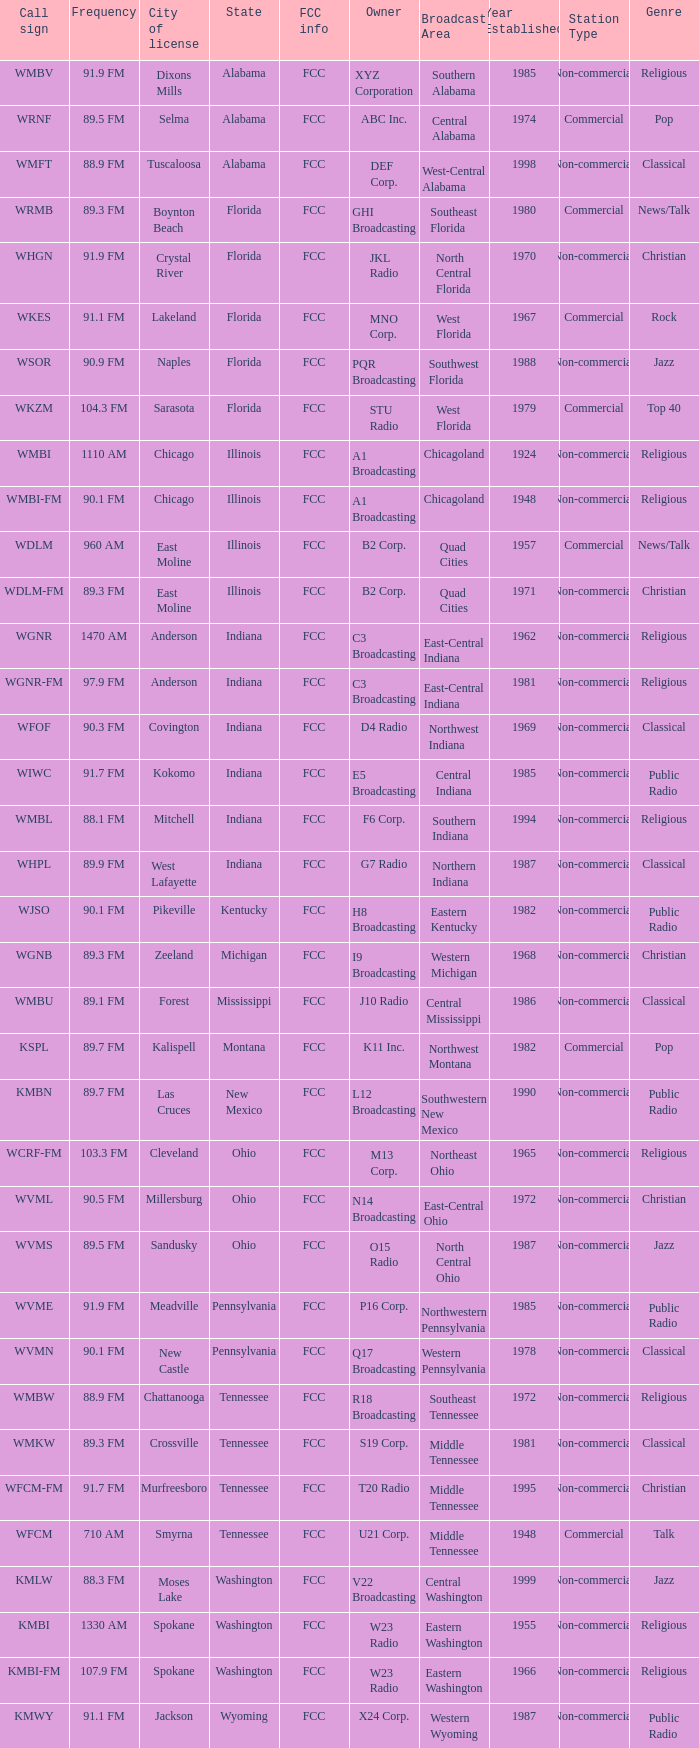What is the frequency of the radio station with a call sign of WGNR-FM? 97.9 FM. 